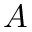<formula> <loc_0><loc_0><loc_500><loc_500>A</formula> 